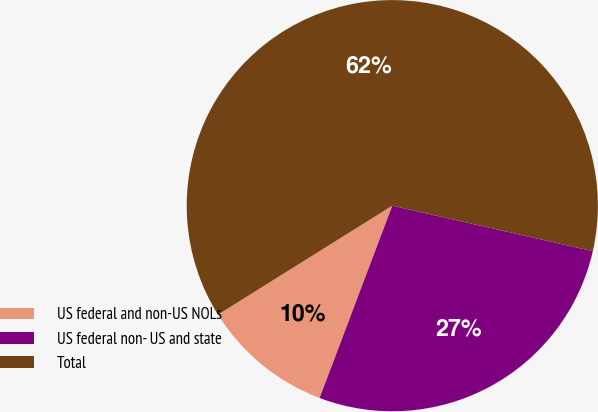Convert chart. <chart><loc_0><loc_0><loc_500><loc_500><pie_chart><fcel>US federal and non-US NOLs<fcel>US federal non- US and state<fcel>Total<nl><fcel>10.36%<fcel>27.2%<fcel>62.44%<nl></chart> 